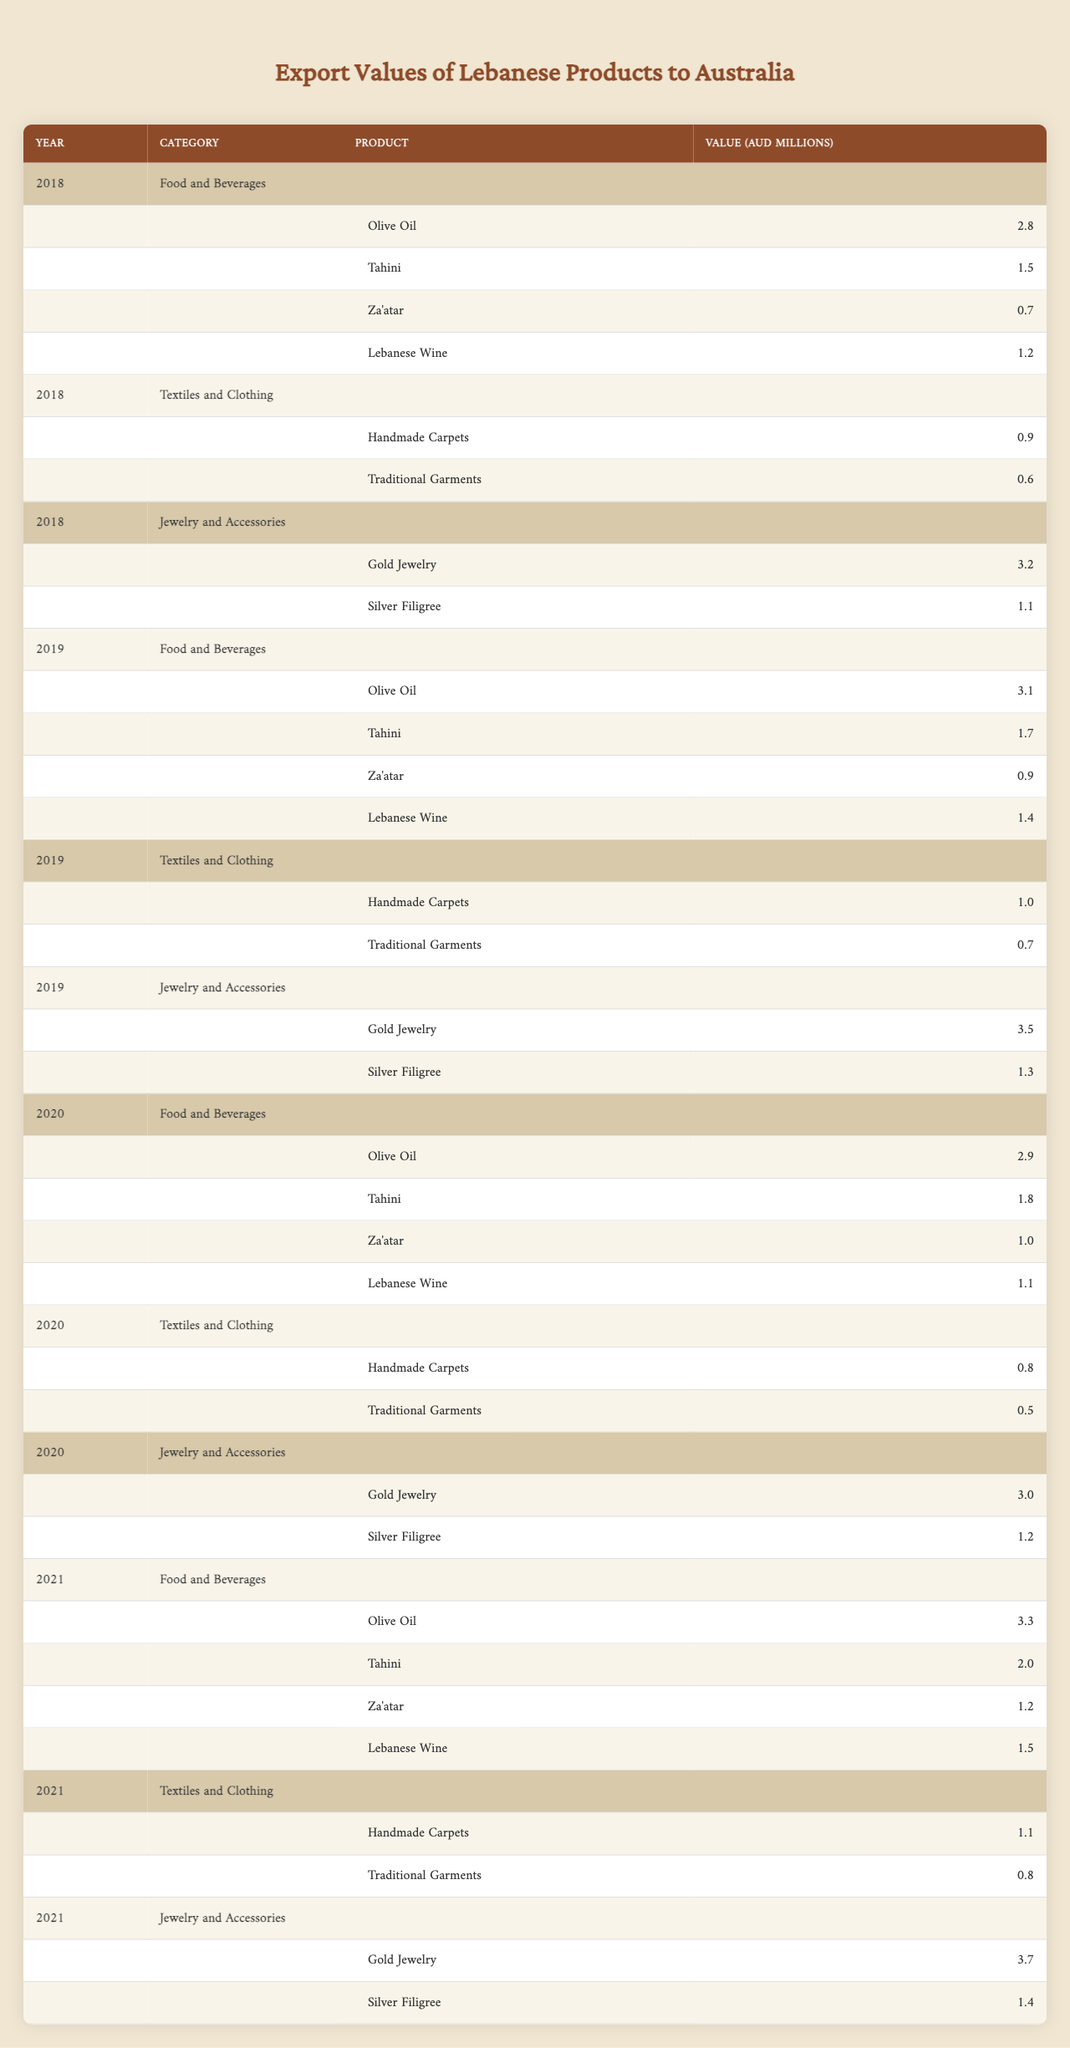What was the export value of Gold Jewelry in 2019? The value of Gold Jewelry for the year 2019 is listed in the table. It shows a value of 3.5 million AUD.
Answer: 3.5 million AUD Which product had the highest export value in the Food and Beverages category in 2021? In 2021, we check the Food and Beverages category and identify that Olive Oil has the highest value at 3.3 million AUD.
Answer: Olive Oil What is the total export value for Food and Beverages in 2020? To find the total for Food and Beverages in 2020, we sum the values: 2.9 (Olive Oil) + 1.8 (Tahini) + 1.0 (Za'atar) + 1.1 (Lebanese Wine) = 6.8 million AUD.
Answer: 6.8 million AUD Did the export value of Silver Filigree increase from 2018 to 2021? We can see the values for Silver Filigree over the years. In 2018, it was 1.1 million AUD and in 2021, it was 1.4 million AUD, indicating an increase.
Answer: Yes What was the average export value of Handmade Carpets across all years? The values for Handmade Carpets are 0.9 (2018), 1.0 (2019), 0.8 (2020), and 1.1 (2021), summing to 3.8. Dividing by 4 years gives an average of 0.95 million AUD.
Answer: 0.95 million AUD Which year had the lowest total export value in the Textiles and Clothing category? We sum the values for Textiles and Clothing across each year: 1.5 (2018), 1.7 (2019), 1.3 (2020), and 1.9 (2021). The lowest total is 1.5 million AUD in 2018.
Answer: 2018 What was the percentage increase in the export value of Tahini from 2018 to 2021? The values for Tahini are: 1.5 in 2018 and 2.0 in 2021. The increase is 2.0 - 1.5 = 0.5, leading to a percentage increase of (0.5/1.5) * 100 = 33.33%.
Answer: 33.33% Was there a decrease in the export value of Lebanese Wine from 2019 to 2020? Checking the values, Lebanese Wine was 1.4 million AUD in 2019 and decreased to 1.1 million AUD in 2020, confirming a decrease.
Answer: Yes What is the total export value of Jewelry and Accessories in 2021? The total for 2021 includes Gold Jewelry (3.7) and Silver Filigree (1.4), resulting in a total of 3.7 + 1.4 = 5.1 million AUD.
Answer: 5.1 million AUD Which product contributed the least to the export value in the Food and Beverages category in 2019? Looking at the Food and Beverages category in 2019, Za'atar had the lowest export value of 0.9 million AUD.
Answer: Za'atar 